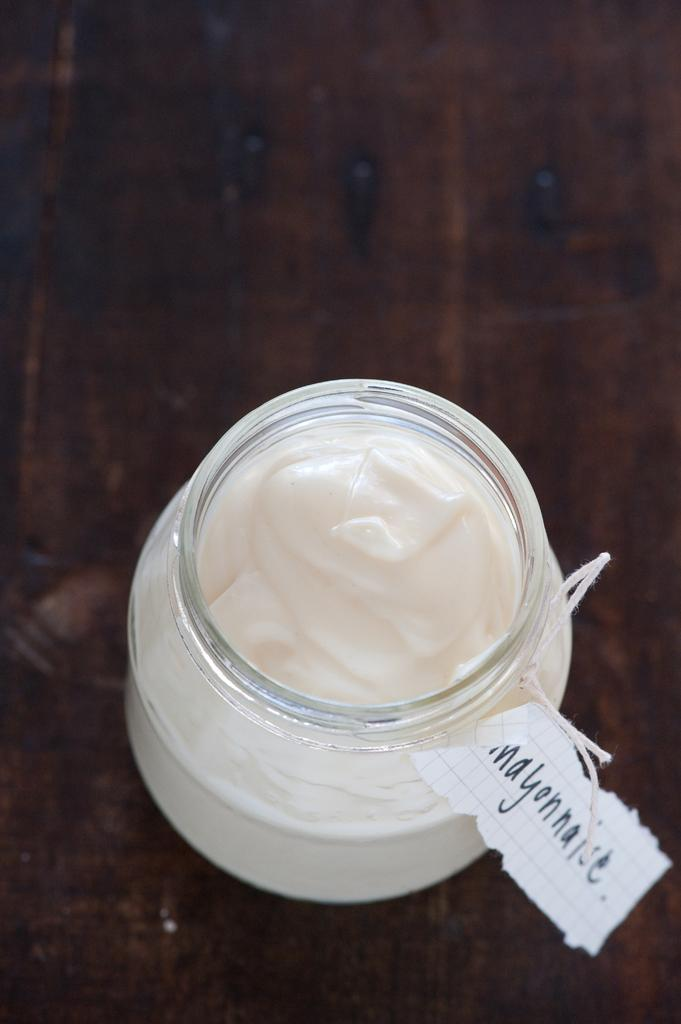<image>
Write a terse but informative summary of the picture. A jar of labeled mayonnaise on a wooden table 